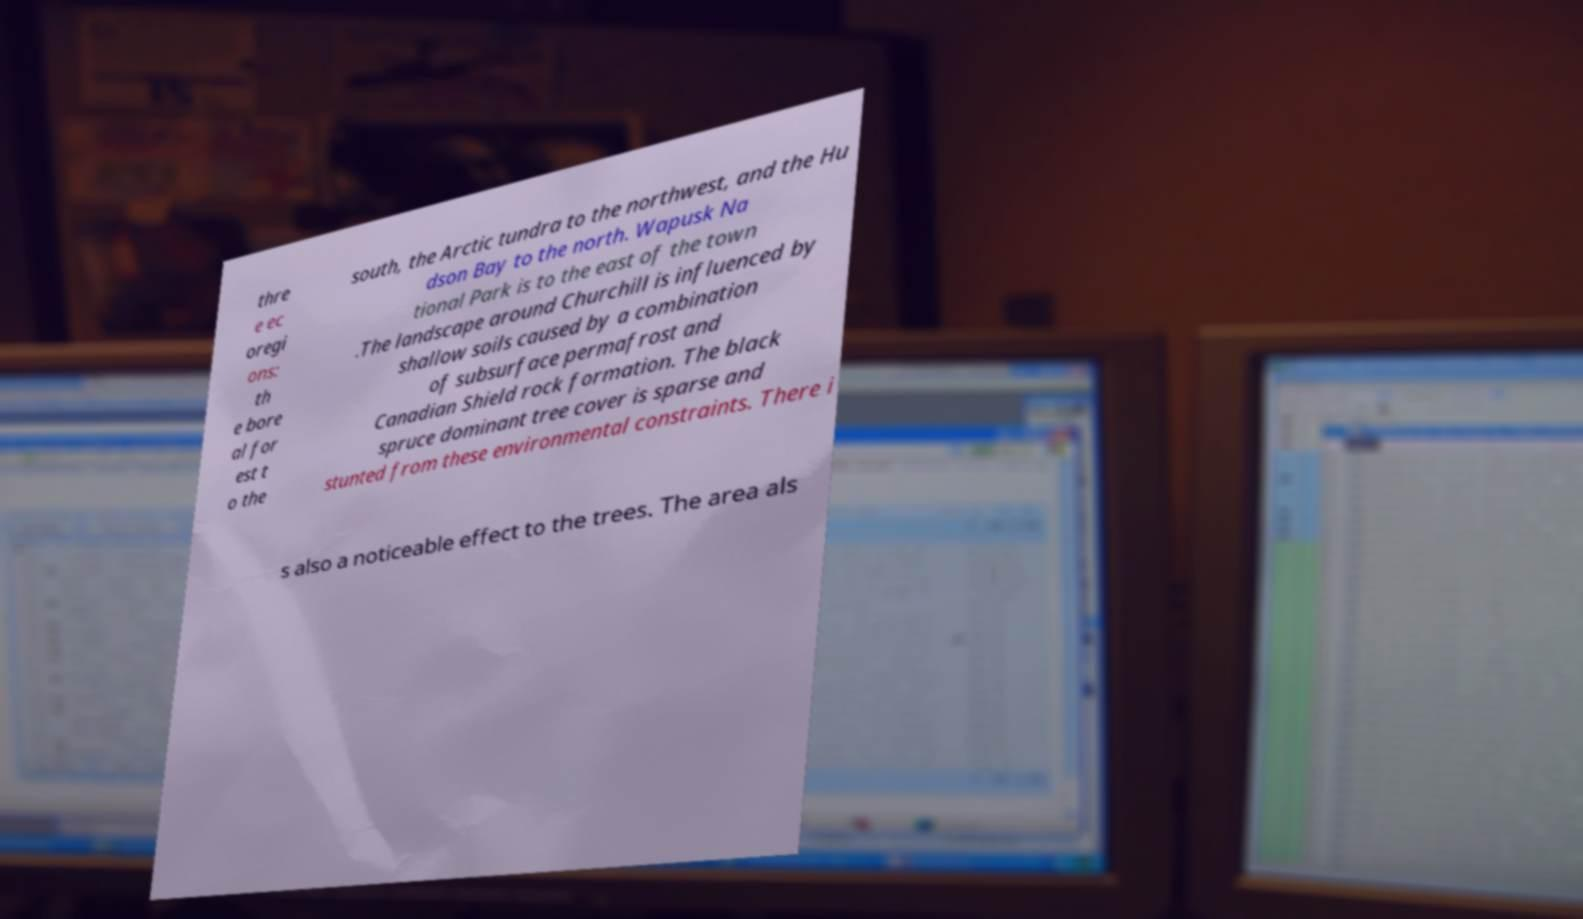I need the written content from this picture converted into text. Can you do that? thre e ec oregi ons: th e bore al for est t o the south, the Arctic tundra to the northwest, and the Hu dson Bay to the north. Wapusk Na tional Park is to the east of the town .The landscape around Churchill is influenced by shallow soils caused by a combination of subsurface permafrost and Canadian Shield rock formation. The black spruce dominant tree cover is sparse and stunted from these environmental constraints. There i s also a noticeable effect to the trees. The area als 